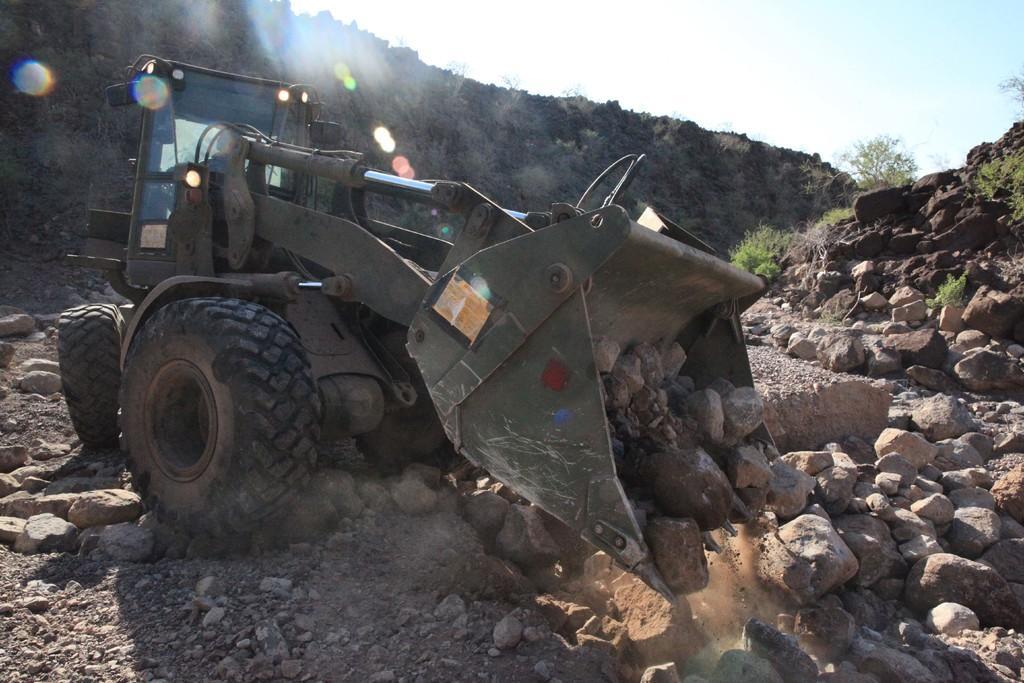Please provide a concise description of this image. In this image in the center there is a vehicle and there are stones. In the background there are rocks and trees. 